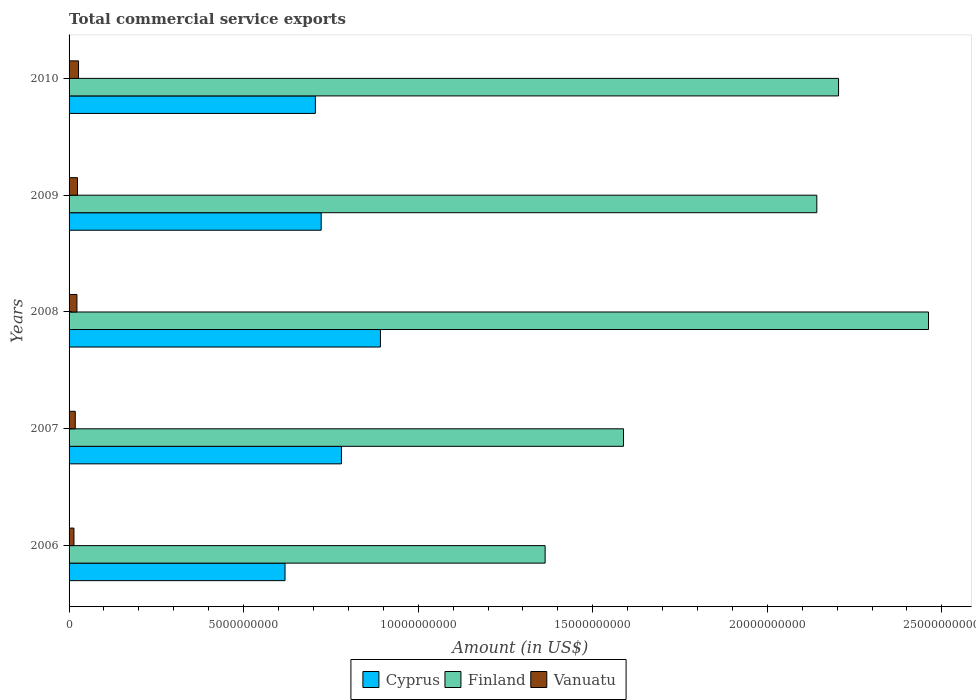How many different coloured bars are there?
Your response must be concise. 3. Are the number of bars per tick equal to the number of legend labels?
Make the answer very short. Yes. In how many cases, is the number of bars for a given year not equal to the number of legend labels?
Your answer should be compact. 0. What is the total commercial service exports in Vanuatu in 2008?
Your response must be concise. 2.25e+08. Across all years, what is the maximum total commercial service exports in Vanuatu?
Offer a terse response. 2.71e+08. Across all years, what is the minimum total commercial service exports in Cyprus?
Provide a short and direct response. 6.19e+09. In which year was the total commercial service exports in Cyprus maximum?
Ensure brevity in your answer.  2008. In which year was the total commercial service exports in Vanuatu minimum?
Offer a very short reply. 2006. What is the total total commercial service exports in Vanuatu in the graph?
Offer a terse response. 1.05e+09. What is the difference between the total commercial service exports in Finland in 2006 and that in 2010?
Your answer should be very brief. -8.40e+09. What is the difference between the total commercial service exports in Vanuatu in 2009 and the total commercial service exports in Finland in 2007?
Provide a short and direct response. -1.56e+1. What is the average total commercial service exports in Finland per year?
Provide a succinct answer. 1.95e+1. In the year 2008, what is the difference between the total commercial service exports in Cyprus and total commercial service exports in Vanuatu?
Your answer should be compact. 8.69e+09. In how many years, is the total commercial service exports in Vanuatu greater than 16000000000 US$?
Offer a very short reply. 0. What is the ratio of the total commercial service exports in Vanuatu in 2006 to that in 2009?
Give a very brief answer. 0.58. What is the difference between the highest and the second highest total commercial service exports in Cyprus?
Offer a terse response. 1.12e+09. What is the difference between the highest and the lowest total commercial service exports in Vanuatu?
Provide a succinct answer. 1.31e+08. In how many years, is the total commercial service exports in Vanuatu greater than the average total commercial service exports in Vanuatu taken over all years?
Keep it short and to the point. 3. Is the sum of the total commercial service exports in Finland in 2007 and 2010 greater than the maximum total commercial service exports in Cyprus across all years?
Offer a very short reply. Yes. What does the 3rd bar from the top in 2007 represents?
Make the answer very short. Cyprus. Is it the case that in every year, the sum of the total commercial service exports in Vanuatu and total commercial service exports in Cyprus is greater than the total commercial service exports in Finland?
Provide a succinct answer. No. How many years are there in the graph?
Provide a short and direct response. 5. How many legend labels are there?
Provide a succinct answer. 3. What is the title of the graph?
Provide a short and direct response. Total commercial service exports. What is the label or title of the X-axis?
Provide a short and direct response. Amount (in US$). What is the Amount (in US$) in Cyprus in 2006?
Your answer should be compact. 6.19e+09. What is the Amount (in US$) of Finland in 2006?
Offer a very short reply. 1.36e+1. What is the Amount (in US$) in Vanuatu in 2006?
Provide a succinct answer. 1.40e+08. What is the Amount (in US$) of Cyprus in 2007?
Offer a very short reply. 7.80e+09. What is the Amount (in US$) of Finland in 2007?
Your response must be concise. 1.59e+1. What is the Amount (in US$) of Vanuatu in 2007?
Ensure brevity in your answer.  1.77e+08. What is the Amount (in US$) of Cyprus in 2008?
Keep it short and to the point. 8.92e+09. What is the Amount (in US$) of Finland in 2008?
Offer a very short reply. 2.46e+1. What is the Amount (in US$) in Vanuatu in 2008?
Offer a very short reply. 2.25e+08. What is the Amount (in US$) in Cyprus in 2009?
Your answer should be very brief. 7.22e+09. What is the Amount (in US$) of Finland in 2009?
Offer a terse response. 2.14e+1. What is the Amount (in US$) in Vanuatu in 2009?
Your response must be concise. 2.41e+08. What is the Amount (in US$) of Cyprus in 2010?
Make the answer very short. 7.05e+09. What is the Amount (in US$) in Finland in 2010?
Your response must be concise. 2.20e+1. What is the Amount (in US$) of Vanuatu in 2010?
Your answer should be compact. 2.71e+08. Across all years, what is the maximum Amount (in US$) of Cyprus?
Make the answer very short. 8.92e+09. Across all years, what is the maximum Amount (in US$) of Finland?
Provide a succinct answer. 2.46e+1. Across all years, what is the maximum Amount (in US$) of Vanuatu?
Provide a short and direct response. 2.71e+08. Across all years, what is the minimum Amount (in US$) in Cyprus?
Keep it short and to the point. 6.19e+09. Across all years, what is the minimum Amount (in US$) of Finland?
Provide a succinct answer. 1.36e+1. Across all years, what is the minimum Amount (in US$) of Vanuatu?
Make the answer very short. 1.40e+08. What is the total Amount (in US$) in Cyprus in the graph?
Make the answer very short. 3.72e+1. What is the total Amount (in US$) in Finland in the graph?
Offer a very short reply. 9.76e+1. What is the total Amount (in US$) in Vanuatu in the graph?
Make the answer very short. 1.05e+09. What is the difference between the Amount (in US$) in Cyprus in 2006 and that in 2007?
Your response must be concise. -1.62e+09. What is the difference between the Amount (in US$) in Finland in 2006 and that in 2007?
Offer a terse response. -2.25e+09. What is the difference between the Amount (in US$) of Vanuatu in 2006 and that in 2007?
Offer a terse response. -3.69e+07. What is the difference between the Amount (in US$) of Cyprus in 2006 and that in 2008?
Offer a terse response. -2.73e+09. What is the difference between the Amount (in US$) of Finland in 2006 and that in 2008?
Make the answer very short. -1.10e+1. What is the difference between the Amount (in US$) in Vanuatu in 2006 and that in 2008?
Offer a terse response. -8.52e+07. What is the difference between the Amount (in US$) in Cyprus in 2006 and that in 2009?
Your answer should be compact. -1.04e+09. What is the difference between the Amount (in US$) of Finland in 2006 and that in 2009?
Your answer should be compact. -7.78e+09. What is the difference between the Amount (in US$) in Vanuatu in 2006 and that in 2009?
Your response must be concise. -1.01e+08. What is the difference between the Amount (in US$) in Cyprus in 2006 and that in 2010?
Your response must be concise. -8.69e+08. What is the difference between the Amount (in US$) in Finland in 2006 and that in 2010?
Give a very brief answer. -8.40e+09. What is the difference between the Amount (in US$) of Vanuatu in 2006 and that in 2010?
Offer a very short reply. -1.31e+08. What is the difference between the Amount (in US$) of Cyprus in 2007 and that in 2008?
Your response must be concise. -1.12e+09. What is the difference between the Amount (in US$) of Finland in 2007 and that in 2008?
Offer a very short reply. -8.74e+09. What is the difference between the Amount (in US$) of Vanuatu in 2007 and that in 2008?
Keep it short and to the point. -4.83e+07. What is the difference between the Amount (in US$) in Cyprus in 2007 and that in 2009?
Ensure brevity in your answer.  5.80e+08. What is the difference between the Amount (in US$) in Finland in 2007 and that in 2009?
Your answer should be compact. -5.54e+09. What is the difference between the Amount (in US$) of Vanuatu in 2007 and that in 2009?
Keep it short and to the point. -6.40e+07. What is the difference between the Amount (in US$) of Cyprus in 2007 and that in 2010?
Make the answer very short. 7.46e+08. What is the difference between the Amount (in US$) in Finland in 2007 and that in 2010?
Your answer should be very brief. -6.16e+09. What is the difference between the Amount (in US$) in Vanuatu in 2007 and that in 2010?
Offer a terse response. -9.42e+07. What is the difference between the Amount (in US$) in Cyprus in 2008 and that in 2009?
Provide a short and direct response. 1.70e+09. What is the difference between the Amount (in US$) in Finland in 2008 and that in 2009?
Provide a short and direct response. 3.20e+09. What is the difference between the Amount (in US$) of Vanuatu in 2008 and that in 2009?
Make the answer very short. -1.57e+07. What is the difference between the Amount (in US$) in Cyprus in 2008 and that in 2010?
Your answer should be very brief. 1.86e+09. What is the difference between the Amount (in US$) in Finland in 2008 and that in 2010?
Ensure brevity in your answer.  2.58e+09. What is the difference between the Amount (in US$) in Vanuatu in 2008 and that in 2010?
Offer a terse response. -4.59e+07. What is the difference between the Amount (in US$) in Cyprus in 2009 and that in 2010?
Keep it short and to the point. 1.67e+08. What is the difference between the Amount (in US$) in Finland in 2009 and that in 2010?
Your answer should be very brief. -6.22e+08. What is the difference between the Amount (in US$) of Vanuatu in 2009 and that in 2010?
Your answer should be very brief. -3.02e+07. What is the difference between the Amount (in US$) in Cyprus in 2006 and the Amount (in US$) in Finland in 2007?
Make the answer very short. -9.70e+09. What is the difference between the Amount (in US$) in Cyprus in 2006 and the Amount (in US$) in Vanuatu in 2007?
Offer a terse response. 6.01e+09. What is the difference between the Amount (in US$) of Finland in 2006 and the Amount (in US$) of Vanuatu in 2007?
Your response must be concise. 1.35e+1. What is the difference between the Amount (in US$) in Cyprus in 2006 and the Amount (in US$) in Finland in 2008?
Make the answer very short. -1.84e+1. What is the difference between the Amount (in US$) of Cyprus in 2006 and the Amount (in US$) of Vanuatu in 2008?
Provide a succinct answer. 5.96e+09. What is the difference between the Amount (in US$) in Finland in 2006 and the Amount (in US$) in Vanuatu in 2008?
Provide a short and direct response. 1.34e+1. What is the difference between the Amount (in US$) in Cyprus in 2006 and the Amount (in US$) in Finland in 2009?
Give a very brief answer. -1.52e+1. What is the difference between the Amount (in US$) of Cyprus in 2006 and the Amount (in US$) of Vanuatu in 2009?
Provide a short and direct response. 5.94e+09. What is the difference between the Amount (in US$) of Finland in 2006 and the Amount (in US$) of Vanuatu in 2009?
Your answer should be compact. 1.34e+1. What is the difference between the Amount (in US$) in Cyprus in 2006 and the Amount (in US$) in Finland in 2010?
Keep it short and to the point. -1.59e+1. What is the difference between the Amount (in US$) of Cyprus in 2006 and the Amount (in US$) of Vanuatu in 2010?
Make the answer very short. 5.91e+09. What is the difference between the Amount (in US$) of Finland in 2006 and the Amount (in US$) of Vanuatu in 2010?
Offer a terse response. 1.34e+1. What is the difference between the Amount (in US$) of Cyprus in 2007 and the Amount (in US$) of Finland in 2008?
Your answer should be very brief. -1.68e+1. What is the difference between the Amount (in US$) in Cyprus in 2007 and the Amount (in US$) in Vanuatu in 2008?
Ensure brevity in your answer.  7.58e+09. What is the difference between the Amount (in US$) of Finland in 2007 and the Amount (in US$) of Vanuatu in 2008?
Your response must be concise. 1.57e+1. What is the difference between the Amount (in US$) in Cyprus in 2007 and the Amount (in US$) in Finland in 2009?
Offer a very short reply. -1.36e+1. What is the difference between the Amount (in US$) of Cyprus in 2007 and the Amount (in US$) of Vanuatu in 2009?
Ensure brevity in your answer.  7.56e+09. What is the difference between the Amount (in US$) of Finland in 2007 and the Amount (in US$) of Vanuatu in 2009?
Give a very brief answer. 1.56e+1. What is the difference between the Amount (in US$) in Cyprus in 2007 and the Amount (in US$) in Finland in 2010?
Your answer should be compact. -1.42e+1. What is the difference between the Amount (in US$) in Cyprus in 2007 and the Amount (in US$) in Vanuatu in 2010?
Your response must be concise. 7.53e+09. What is the difference between the Amount (in US$) in Finland in 2007 and the Amount (in US$) in Vanuatu in 2010?
Your answer should be very brief. 1.56e+1. What is the difference between the Amount (in US$) in Cyprus in 2008 and the Amount (in US$) in Finland in 2009?
Make the answer very short. -1.25e+1. What is the difference between the Amount (in US$) in Cyprus in 2008 and the Amount (in US$) in Vanuatu in 2009?
Offer a terse response. 8.68e+09. What is the difference between the Amount (in US$) in Finland in 2008 and the Amount (in US$) in Vanuatu in 2009?
Your answer should be compact. 2.44e+1. What is the difference between the Amount (in US$) in Cyprus in 2008 and the Amount (in US$) in Finland in 2010?
Offer a very short reply. -1.31e+1. What is the difference between the Amount (in US$) in Cyprus in 2008 and the Amount (in US$) in Vanuatu in 2010?
Make the answer very short. 8.65e+09. What is the difference between the Amount (in US$) in Finland in 2008 and the Amount (in US$) in Vanuatu in 2010?
Give a very brief answer. 2.43e+1. What is the difference between the Amount (in US$) in Cyprus in 2009 and the Amount (in US$) in Finland in 2010?
Your response must be concise. -1.48e+1. What is the difference between the Amount (in US$) of Cyprus in 2009 and the Amount (in US$) of Vanuatu in 2010?
Your answer should be very brief. 6.95e+09. What is the difference between the Amount (in US$) in Finland in 2009 and the Amount (in US$) in Vanuatu in 2010?
Offer a terse response. 2.11e+1. What is the average Amount (in US$) in Cyprus per year?
Keep it short and to the point. 7.44e+09. What is the average Amount (in US$) of Finland per year?
Your answer should be compact. 1.95e+1. What is the average Amount (in US$) in Vanuatu per year?
Give a very brief answer. 2.11e+08. In the year 2006, what is the difference between the Amount (in US$) of Cyprus and Amount (in US$) of Finland?
Offer a terse response. -7.45e+09. In the year 2006, what is the difference between the Amount (in US$) of Cyprus and Amount (in US$) of Vanuatu?
Your answer should be compact. 6.05e+09. In the year 2006, what is the difference between the Amount (in US$) in Finland and Amount (in US$) in Vanuatu?
Your response must be concise. 1.35e+1. In the year 2007, what is the difference between the Amount (in US$) in Cyprus and Amount (in US$) in Finland?
Ensure brevity in your answer.  -8.08e+09. In the year 2007, what is the difference between the Amount (in US$) in Cyprus and Amount (in US$) in Vanuatu?
Offer a terse response. 7.62e+09. In the year 2007, what is the difference between the Amount (in US$) in Finland and Amount (in US$) in Vanuatu?
Offer a terse response. 1.57e+1. In the year 2008, what is the difference between the Amount (in US$) of Cyprus and Amount (in US$) of Finland?
Ensure brevity in your answer.  -1.57e+1. In the year 2008, what is the difference between the Amount (in US$) in Cyprus and Amount (in US$) in Vanuatu?
Your answer should be very brief. 8.69e+09. In the year 2008, what is the difference between the Amount (in US$) of Finland and Amount (in US$) of Vanuatu?
Your response must be concise. 2.44e+1. In the year 2009, what is the difference between the Amount (in US$) in Cyprus and Amount (in US$) in Finland?
Your answer should be very brief. -1.42e+1. In the year 2009, what is the difference between the Amount (in US$) in Cyprus and Amount (in US$) in Vanuatu?
Ensure brevity in your answer.  6.98e+09. In the year 2009, what is the difference between the Amount (in US$) of Finland and Amount (in US$) of Vanuatu?
Your response must be concise. 2.12e+1. In the year 2010, what is the difference between the Amount (in US$) in Cyprus and Amount (in US$) in Finland?
Give a very brief answer. -1.50e+1. In the year 2010, what is the difference between the Amount (in US$) in Cyprus and Amount (in US$) in Vanuatu?
Provide a short and direct response. 6.78e+09. In the year 2010, what is the difference between the Amount (in US$) in Finland and Amount (in US$) in Vanuatu?
Keep it short and to the point. 2.18e+1. What is the ratio of the Amount (in US$) in Cyprus in 2006 to that in 2007?
Keep it short and to the point. 0.79. What is the ratio of the Amount (in US$) in Finland in 2006 to that in 2007?
Your response must be concise. 0.86. What is the ratio of the Amount (in US$) in Vanuatu in 2006 to that in 2007?
Your answer should be very brief. 0.79. What is the ratio of the Amount (in US$) in Cyprus in 2006 to that in 2008?
Ensure brevity in your answer.  0.69. What is the ratio of the Amount (in US$) of Finland in 2006 to that in 2008?
Your answer should be compact. 0.55. What is the ratio of the Amount (in US$) in Vanuatu in 2006 to that in 2008?
Give a very brief answer. 0.62. What is the ratio of the Amount (in US$) of Cyprus in 2006 to that in 2009?
Make the answer very short. 0.86. What is the ratio of the Amount (in US$) of Finland in 2006 to that in 2009?
Offer a terse response. 0.64. What is the ratio of the Amount (in US$) in Vanuatu in 2006 to that in 2009?
Keep it short and to the point. 0.58. What is the ratio of the Amount (in US$) in Cyprus in 2006 to that in 2010?
Ensure brevity in your answer.  0.88. What is the ratio of the Amount (in US$) in Finland in 2006 to that in 2010?
Give a very brief answer. 0.62. What is the ratio of the Amount (in US$) in Vanuatu in 2006 to that in 2010?
Your answer should be very brief. 0.52. What is the ratio of the Amount (in US$) of Cyprus in 2007 to that in 2008?
Offer a very short reply. 0.87. What is the ratio of the Amount (in US$) of Finland in 2007 to that in 2008?
Provide a short and direct response. 0.65. What is the ratio of the Amount (in US$) of Vanuatu in 2007 to that in 2008?
Keep it short and to the point. 0.79. What is the ratio of the Amount (in US$) of Cyprus in 2007 to that in 2009?
Provide a succinct answer. 1.08. What is the ratio of the Amount (in US$) of Finland in 2007 to that in 2009?
Offer a terse response. 0.74. What is the ratio of the Amount (in US$) of Vanuatu in 2007 to that in 2009?
Provide a succinct answer. 0.73. What is the ratio of the Amount (in US$) in Cyprus in 2007 to that in 2010?
Offer a terse response. 1.11. What is the ratio of the Amount (in US$) in Finland in 2007 to that in 2010?
Provide a succinct answer. 0.72. What is the ratio of the Amount (in US$) in Vanuatu in 2007 to that in 2010?
Provide a succinct answer. 0.65. What is the ratio of the Amount (in US$) in Cyprus in 2008 to that in 2009?
Your answer should be very brief. 1.24. What is the ratio of the Amount (in US$) in Finland in 2008 to that in 2009?
Your response must be concise. 1.15. What is the ratio of the Amount (in US$) of Vanuatu in 2008 to that in 2009?
Offer a terse response. 0.93. What is the ratio of the Amount (in US$) in Cyprus in 2008 to that in 2010?
Give a very brief answer. 1.26. What is the ratio of the Amount (in US$) in Finland in 2008 to that in 2010?
Your answer should be compact. 1.12. What is the ratio of the Amount (in US$) in Vanuatu in 2008 to that in 2010?
Your answer should be compact. 0.83. What is the ratio of the Amount (in US$) of Cyprus in 2009 to that in 2010?
Offer a terse response. 1.02. What is the ratio of the Amount (in US$) in Finland in 2009 to that in 2010?
Offer a very short reply. 0.97. What is the ratio of the Amount (in US$) of Vanuatu in 2009 to that in 2010?
Your answer should be compact. 0.89. What is the difference between the highest and the second highest Amount (in US$) in Cyprus?
Give a very brief answer. 1.12e+09. What is the difference between the highest and the second highest Amount (in US$) in Finland?
Provide a succinct answer. 2.58e+09. What is the difference between the highest and the second highest Amount (in US$) in Vanuatu?
Your answer should be very brief. 3.02e+07. What is the difference between the highest and the lowest Amount (in US$) of Cyprus?
Provide a succinct answer. 2.73e+09. What is the difference between the highest and the lowest Amount (in US$) of Finland?
Give a very brief answer. 1.10e+1. What is the difference between the highest and the lowest Amount (in US$) in Vanuatu?
Your response must be concise. 1.31e+08. 